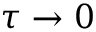<formula> <loc_0><loc_0><loc_500><loc_500>\tau \rightarrow 0</formula> 